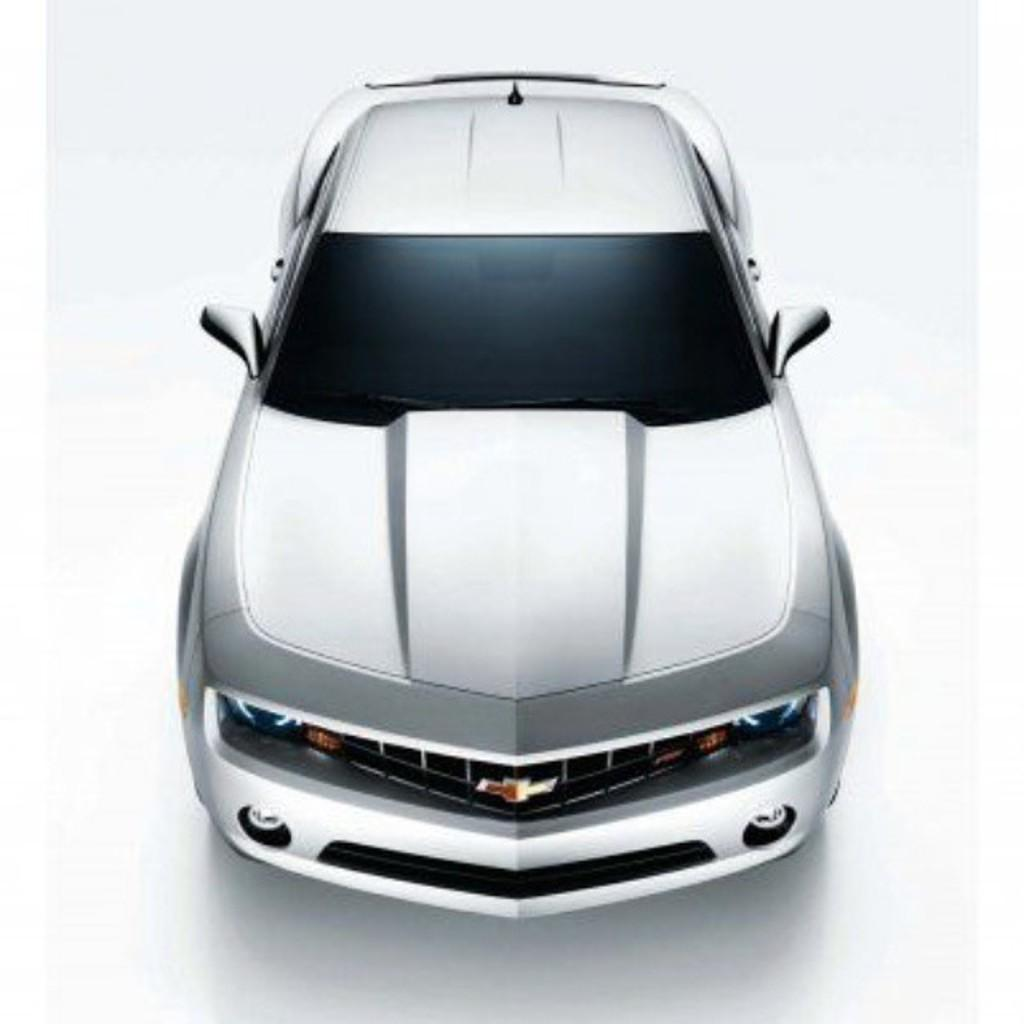What is the main subject of the image? The main subject of the image is a car. Can you describe the car's position in the image? The car is on a surface in the image. What color is the car? The car is white in color. What type of behavior does the pocket exhibit in the image? There is no pocket present in the image, so it cannot exhibit any behavior. 